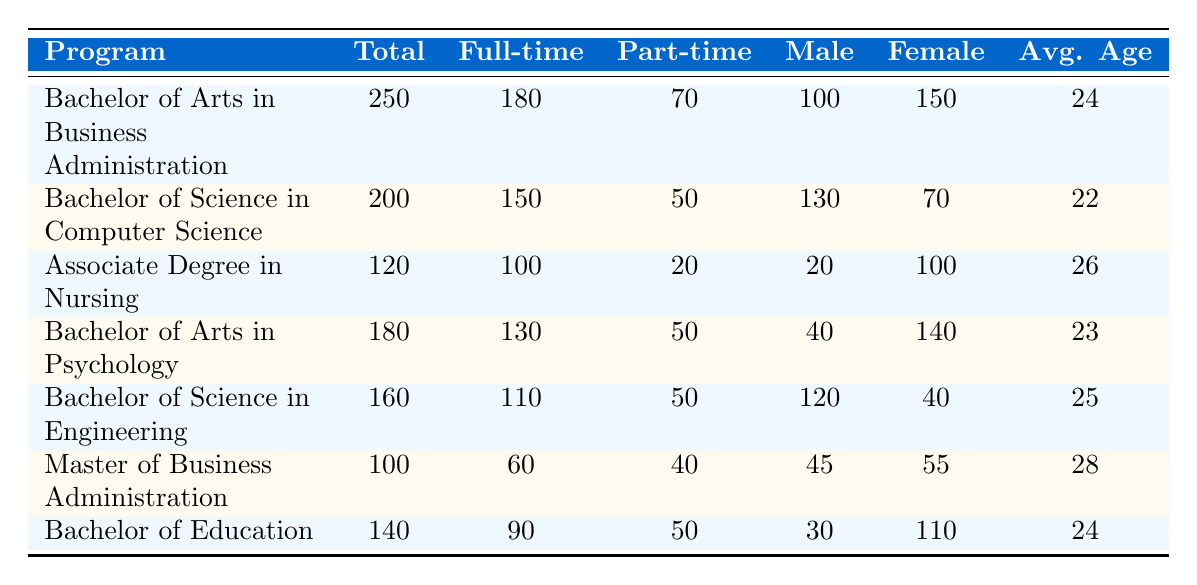What is the total enrollment for the Bachelor of Arts in Business Administration program? The total enrollment for the Bachelor of Arts in Business Administration program is listed directly in the table under the "Total" column. The value provided is 250.
Answer: 250 How many full-time students are enrolled in the Bachelor of Science in Computer Science? The number of full-time students is found in the column labeled "Full-time" corresponding to the Bachelor of Science in Computer Science program, which shows a total of 150 full-time students.
Answer: 150 Is the number of male students in the Associate Degree in Nursing greater than the number of international students in that program? The table shows that there are 20 male students in the Associate Degree in Nursing program and 5 international students. Since 20 is greater than 5, the answer is yes.
Answer: Yes What is the average age of students in the Bachelor of Education program? The average age is presented in the column labeled "Avg. Age" for the Bachelor of Education program, with the listed average age being 24.
Answer: 24 How many part-time students are enrolled across all programs combined? To find the total number of part-time students, I need to add the values listed under the "Part-time" column for all programs: 70 + 50 + 20 + 50 + 50 + 40 + 50 = 330. Thus, there are 330 part-time students in total.
Answer: 330 Which program has the highest number of international students, and what is that number? By comparing the values under "international students" for each program, the Bachelor of Business Administration has 15, the Bachelor of Science in Computer Science has 10, the Associate Degree in Nursing has 5, and so forth. The program with the highest number is the Master of Business Administration with 20 international students.
Answer: Master of Business Administration; 20 What is the total difference in full-time students between the Bachelor of Science in Engineering and the Bachelor of Arts in Psychology? The full-time students in the Bachelor of Science in Engineering is 110 and in the Bachelor of Arts in Psychology is 130. The difference is 130 - 110 = 20.
Answer: 20 Are there more female students than male students in the Bachelor of Arts in Psychology program? The gender distribution shows 40 male students and 140 female students in the Bachelor of Arts in Psychology program. Since 140 is greater than 40, the answer is yes.
Answer: Yes What is the total enrollment for all programs combined? To find the total enrollment across all programs, I need to add the values from the "Total" column: 250 + 200 + 120 + 180 + 160 + 100 + 140 = 1150. The total enrollment is 1150.
Answer: 1150 